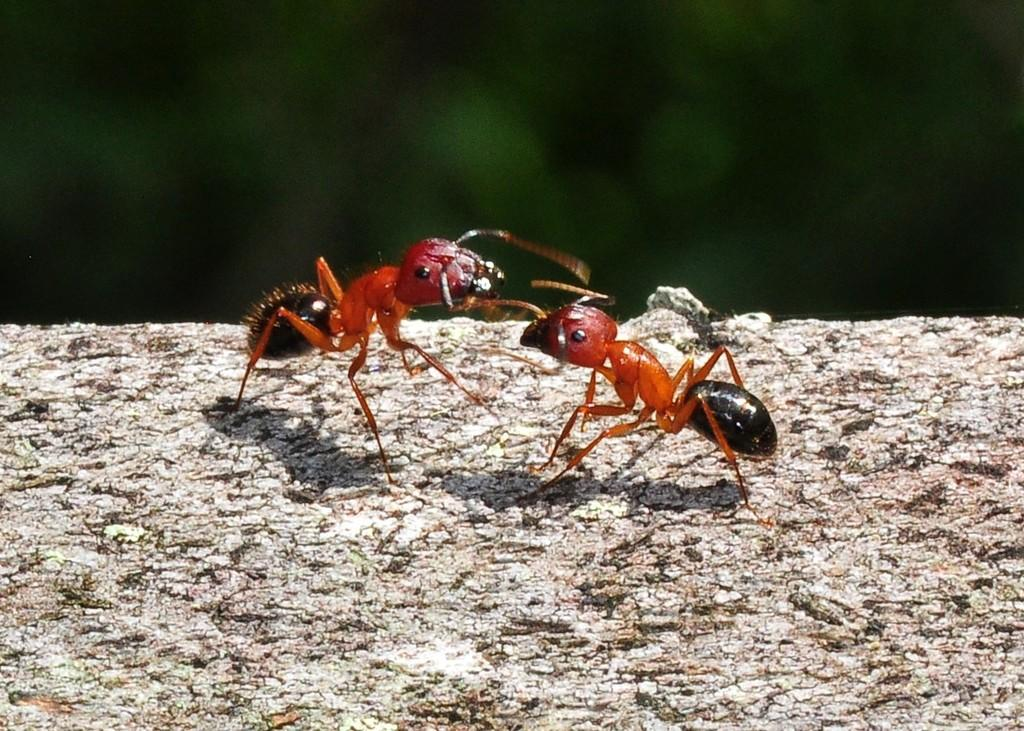What type of insects are present in the image? There are two ants in the image. Where are the ants located? The ants are on a wooden log. What type of trouble are the ants causing in the image? There is no indication of any trouble caused by the ants in the image. What experience do the ants have in the image? There is no information about the ants' experience in the image. Are the police present in the image? There is no mention of the police or any law enforcement in the image. 